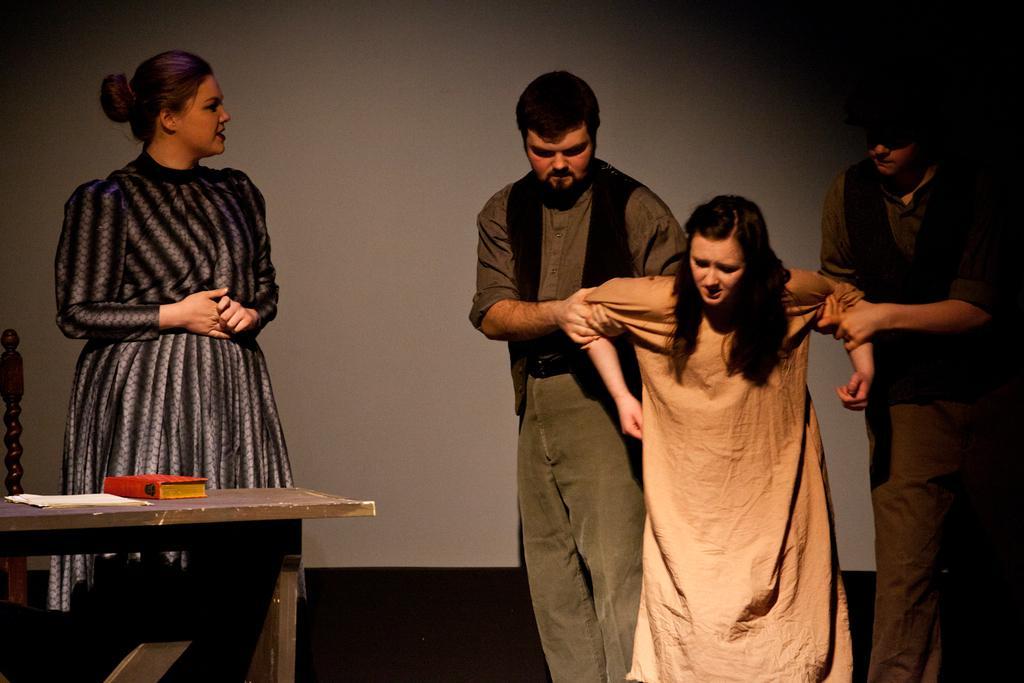Can you describe this image briefly? in this picture we can see four people two men and two women, I think they are acting in a play, on the left side of the image we can see a table which consists of a book. 